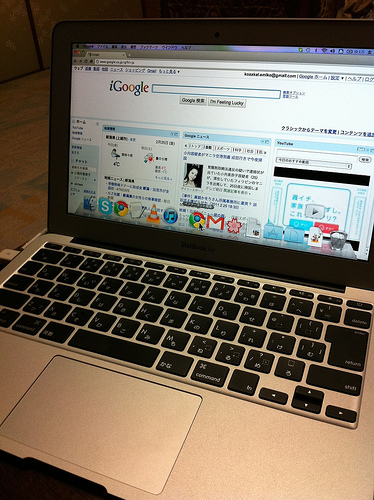<image>
Is the chrome above the itunes? No. The chrome is not positioned above the itunes. The vertical arrangement shows a different relationship. Is the moniter in front of the keyboard? Yes. The moniter is positioned in front of the keyboard, appearing closer to the camera viewpoint. 